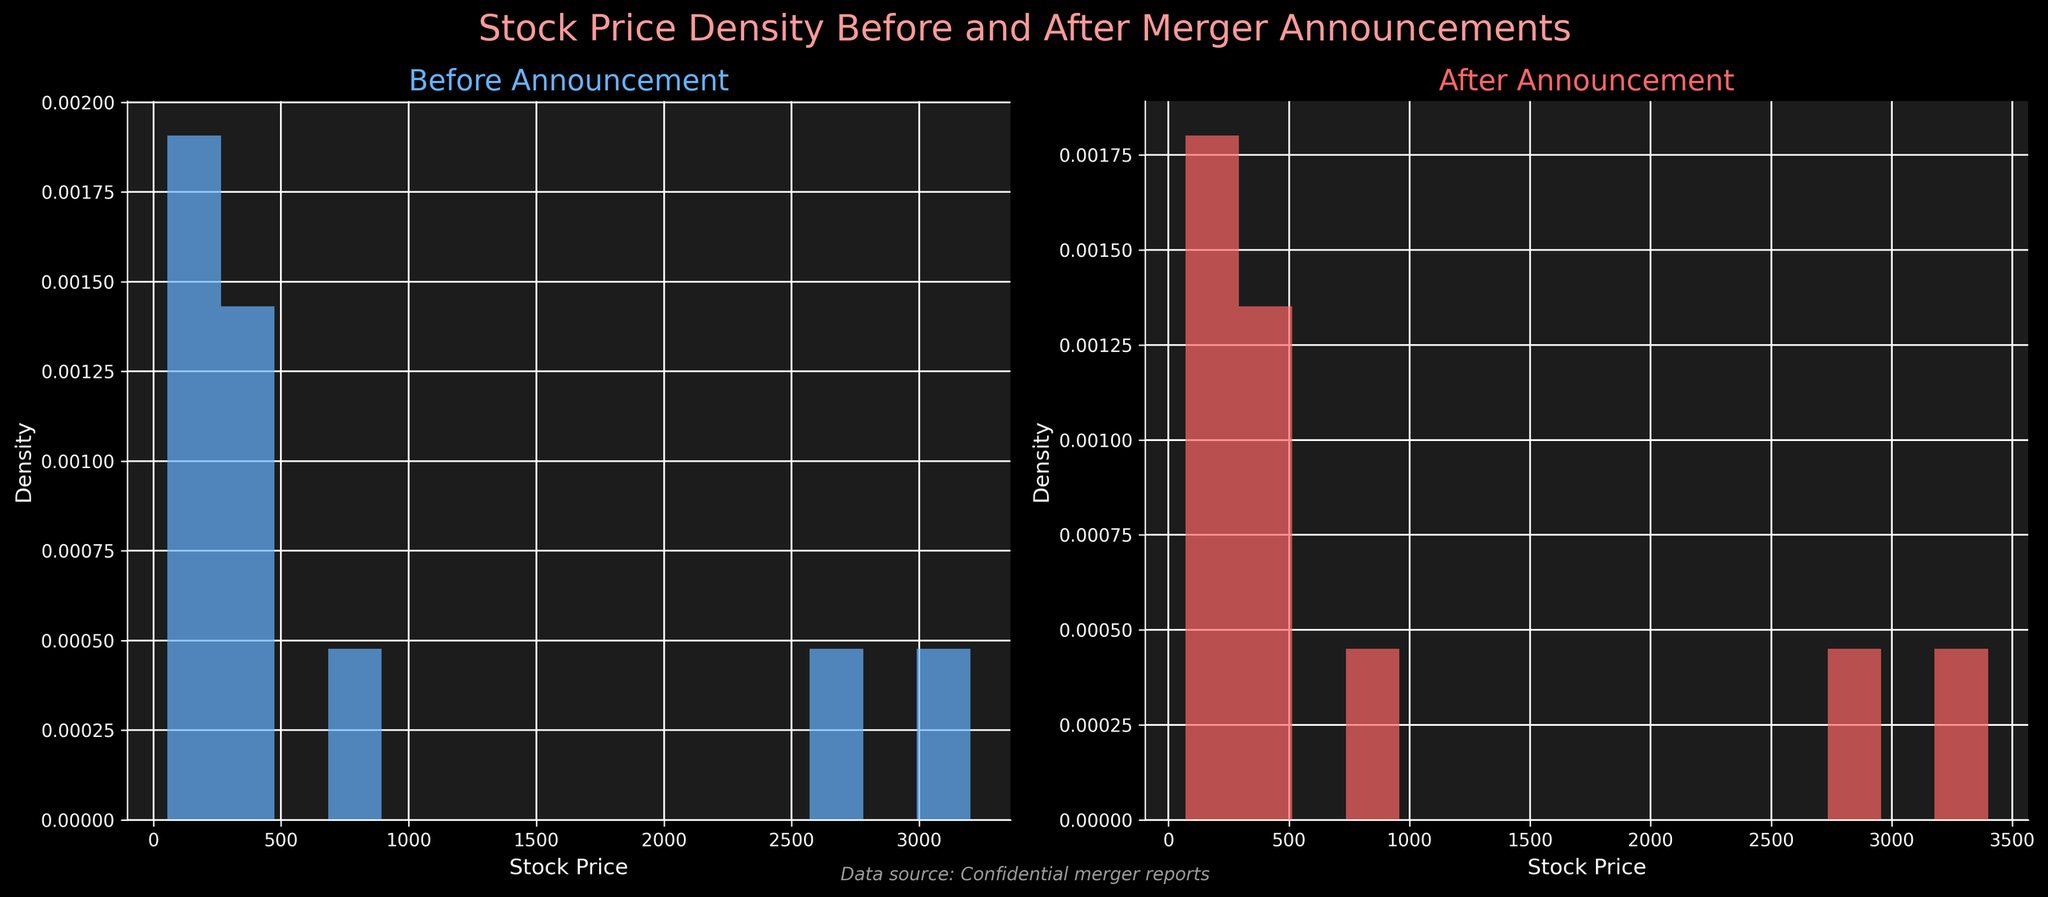What are the titles of the two subplots? The titles of the subplots are the text displayed at the top of each subplot. In this case, the left subplot is titled "Before Announcement" and the right subplot is titled "After Announcement."
Answer: "Before Announcement" and "After Announcement" What do the x-axes of the subplots represent? The x-axes of the subplots show the stock prices of the companies before and after the merger announcements, as indicated by the labels "Stock Price" on both x-axes.
Answer: Stock Price What is the data source mentioned in the figure? The data source is specified in the text at the bottom of the figure, which reads "Data source: Confidential merger reports."
Answer: Confidential merger reports How does the density of stock prices compare before and after the announcements? By examining the histograms, we can see that the density of stock prices before the announcements has a wider spread, while after the announcements, the density seems more concentrated.
Answer: Wider spread before, more concentrated after Which color represents the stock prices before the announcement? The left subplot, which shows stock prices before the announcement, uses a blue color with the density indicated by the bars.
Answer: Blue Which subplot indicates higher stock prices on average, before or after the announcement? The subplot on the right, representing stock prices after the announcement is generally higher. This conclusion stems from observing the shift in the density curve to the right compared to the left subplot (before the announcement).
Answer: After the announcement What is a noticeable difference in the density plot shapes between the two subplots? A noticeable difference is that the density plot for before the announcement has more dispersion and peaks at lower values, while after the announcement, it shows a shift towards higher values and is less spread out.
Answer: More dispersed before, shifted higher after How does the density of stock prices below $200 compare across the two subplots? There is a higher density of stock prices below $200 in the subplot before the announcement compared to the subplot after the announcement. This is evident from the taller bars in the $0-$200 range in the left subplot.
Answer: Higher before the announcement What does the density plot after the announcement tell us about the stock prices? The density plot after the announcement shows a concentration of stock prices at higher values, suggesting that stock prices generally increased after the merger announcements. This is seen by the higher peaks at the upper range of the x-axis in the right subplot.
Answer: Stock prices generally increased How can we interpret the lower part of the histogram bars in the "After Announcement" subplot? The histogram bars in the "After Announcement" subplot, especially at lower stock prices, are smaller, indicating that fewer companies have stock prices at the lower range post-announcement compared to pre-announcement.
Answer: Fewer companies at lower prices after announcement 